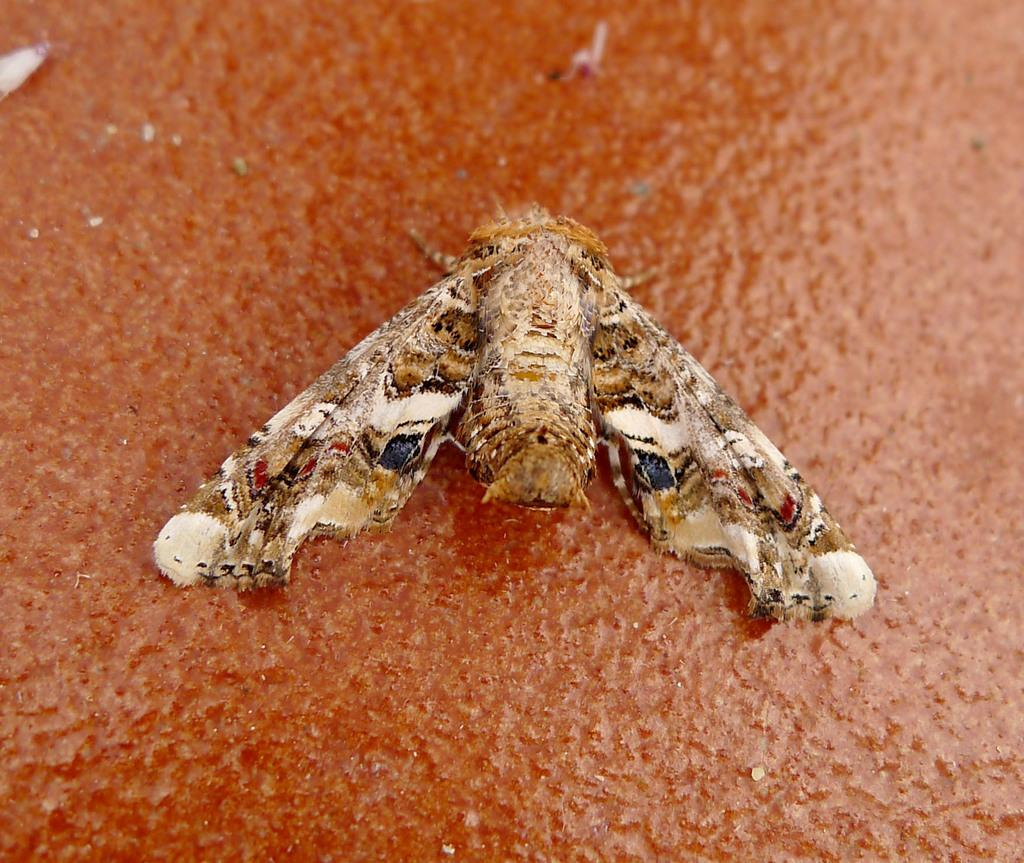What type of creature can be seen in the image? There is an insect in the image. How many pizzas are being served on the boat by the guide in the image? There is no boat, guide, or pizzas present in the image; it only features an insect. 